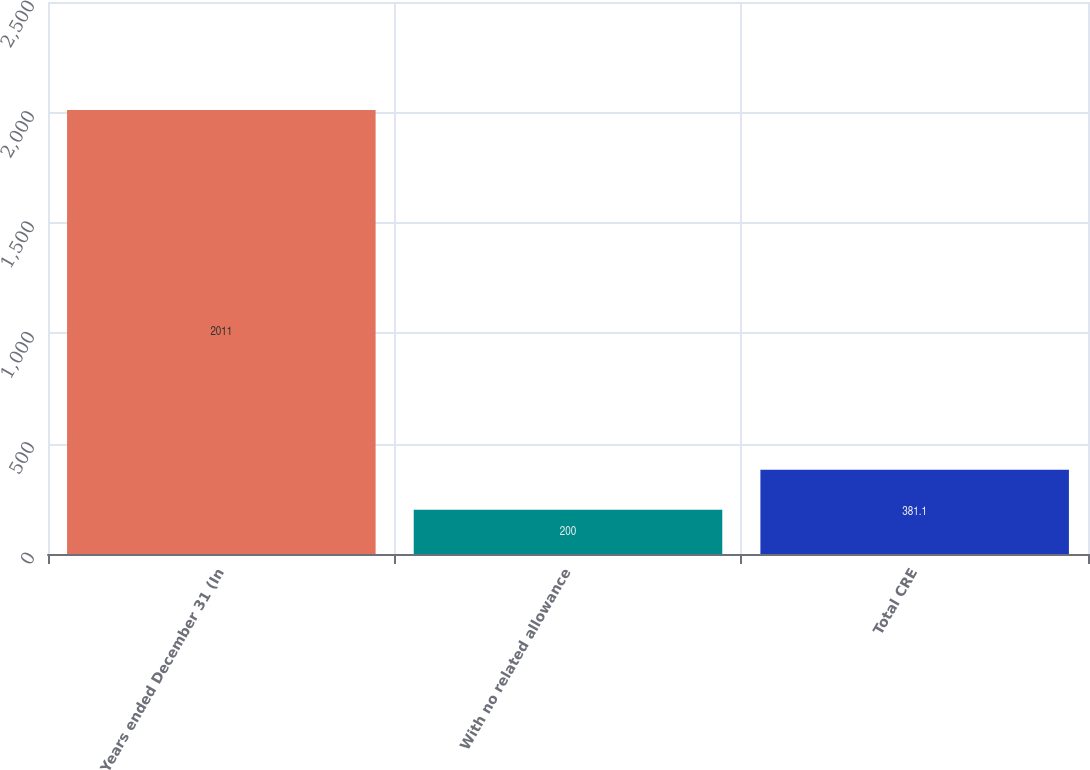<chart> <loc_0><loc_0><loc_500><loc_500><bar_chart><fcel>Years ended December 31 (In<fcel>With no related allowance<fcel>Total CRE<nl><fcel>2011<fcel>200<fcel>381.1<nl></chart> 